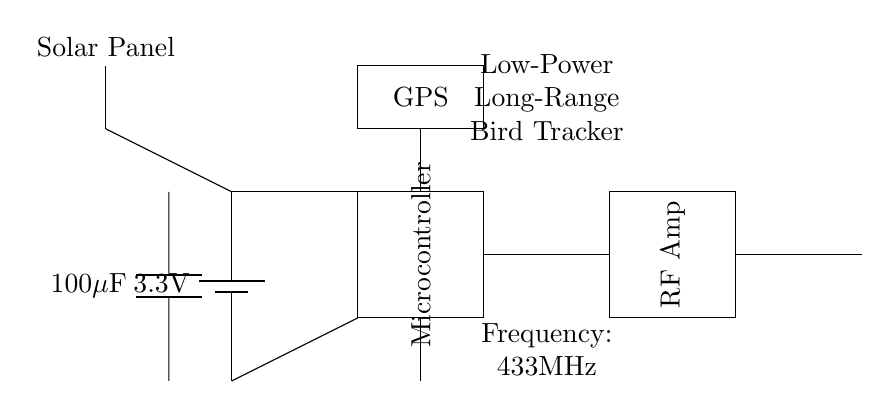What is the power supply voltage? The power supply is labeled as a battery with a voltage of 3.3V, which shows the potential difference supplied to the circuit.
Answer: 3.3V What is the purpose of the GPS in this circuit? The GPS module is included for tracking purposes, allowing the device to determine its geographic location, necessary for bird migration tracking.
Answer: Tracking What component is responsible for amplifying the radio frequency signal? The RF Amplifier, marked as RF Amp in the circuit, is specifically designated for boosting the radio frequency signals to facilitate long-range communication.
Answer: RF Amplifier What frequency does this device operate on? The circuit notes that it operates at a frequency of 433 megahertz, which is a common frequency used for low-power, long-range radio communication.
Answer: 433 megahertz How is the circuit powered in addition to the battery? The presence of the solar panel indicates that the device can be powered by solar energy, enabling it to function without relying solely on the battery.
Answer: Solar panel Why is the capacitor included in this circuit? The capacitor is used for power smoothing, helping to stabilize voltage levels in the circuit by storing and releasing energy when needed, which contributes to the overall reliability of the device.
Answer: Power smoothing 